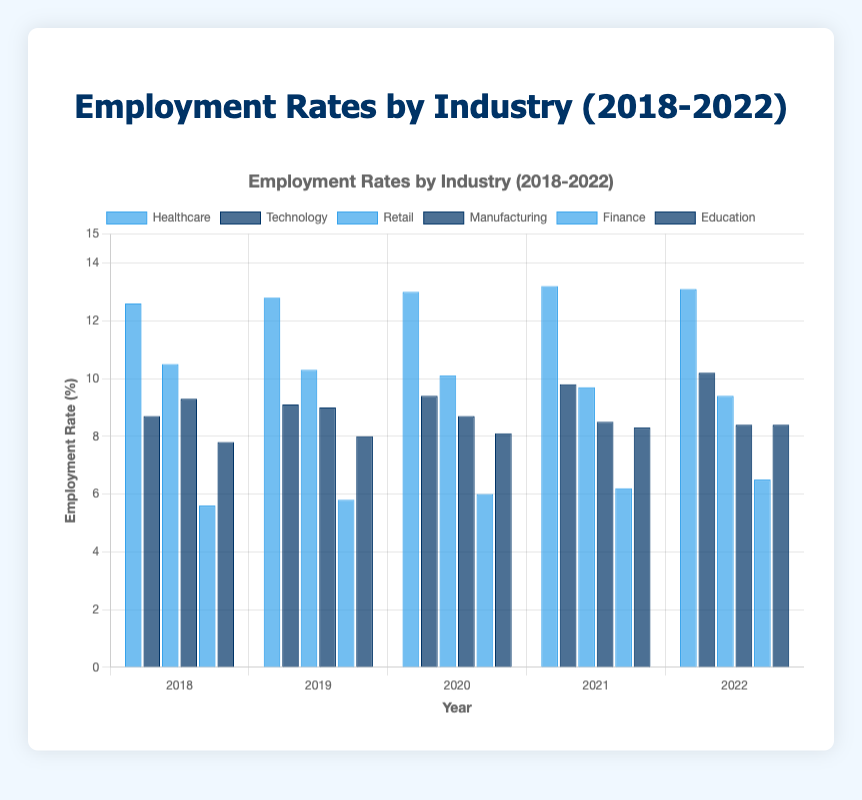Which industry had the highest employment rate in 2022? To identify the industry with the highest employment rate in 2022, look for the tallest bar for the year 2022. In this case, Healthcare has the highest employment rate for 2022.
Answer: Healthcare Which industry experienced the greatest increase in employment rates from 2018 to 2022? Calculate the difference between the employment rates for 2022 and 2018 for each industry and find the maximum difference. Technology increased from 8.7% to 10.2%, which is the highest increase of 1.5%.
Answer: Technology What was the average employment rate for the Manufacturing industry over the five years? Add the employment rates for Manufacturing from 2018 to 2022 and divide by the number of years: (9.3 + 9.0 + 8.7 + 8.5 + 8.4) / 5 = 43.9 / 5 = 8.78.
Answer: 8.78 How did the employment rate in the Retail industry change from 2019 to 2021? Look at Retail's employment rates for 2019 and 2021 and calculate the difference: 10.3% in 2019 and 9.7% in 2021, so the change is 10.3 - 9.7 = 0.6%.
Answer: Decreased by 0.6% Which two industries had almost equal employment rates in 2022? Compare the 2022 employment rates for all industries and find close values. Finance (6.5%) and Education (8.4%) are close, but Finance and Education don't match well. On closer inspection, none are near identical. The closest might be Finance’s 6.5% and Healthcare’s 13.1%.
Answer: None are almost equal What was the trend in the employment rate for the Healthcare industry from 2018 to 2022? Look at the Healthcare rates from 2018 to 2022: 12.6%, 12.8%, 13.0%, 13.2%, and 13.1%. There is an increasing trend till 2021 and then a slight drop in 2022.
Answer: Mostly increasing, slight drop in 2022 Did the employment rate in the Technology industry consistently rise from 2018 to 2022? Review the Technology rates for the given years: 8.7%, 9.1%, 9.4%, 9.8%, and 10.2%. Each year the rate increases from the previous year.
Answer: Yes Between which years did the Finance industry experience the highest rate of growth? Calculate the annual increase and identify the largest: 2018-2019 (5.6 to 5.8), 2019-2020 (5.8 to 6.0), 2020-2021 (6.0 to 6.2), 2021-2022 (6.2 to 6.5). The largest increase was between 2021 and 2022, an increase of 0.3%.
Answer: 2021-2022 By how much did the employment rate in Education change from 2018 to 2022? Subtract the 2018 rate from the 2022 rate for Education: 8.4 - 7.8 = 0.6%.
Answer: Increased by 0.6% What was the employment rate for Retail in 2020, and how did it compare to 2018? The 2020 rate was 10.1%, down from 10.5% in 2018. The difference is 10.5 - 10.1 = 0.4%.
Answer: 10.1%, decreased by 0.4% 